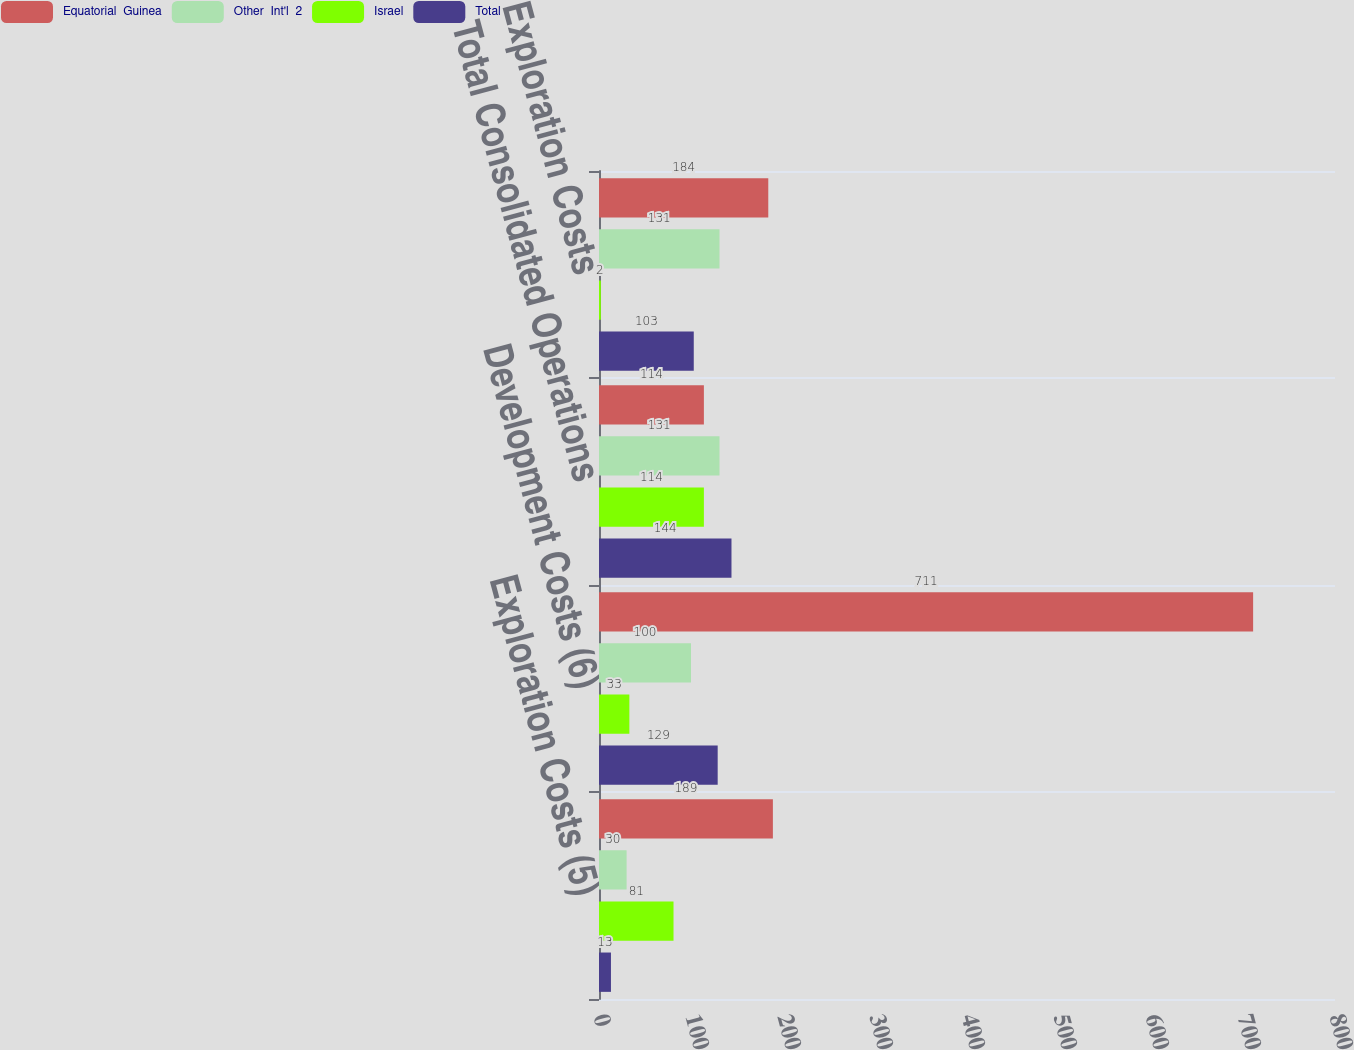Convert chart. <chart><loc_0><loc_0><loc_500><loc_500><stacked_bar_chart><ecel><fcel>Exploration Costs (5)<fcel>Development Costs (6)<fcel>Total Consolidated Operations<fcel>Exploration Costs<nl><fcel>Equatorial  Guinea<fcel>189<fcel>711<fcel>114<fcel>184<nl><fcel>Other  Int'l  2<fcel>30<fcel>100<fcel>131<fcel>131<nl><fcel>Israel<fcel>81<fcel>33<fcel>114<fcel>2<nl><fcel>Total<fcel>13<fcel>129<fcel>144<fcel>103<nl></chart> 